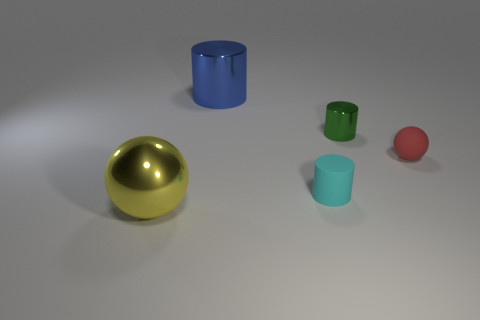There is a tiny green thing; is its shape the same as the big shiny thing in front of the red object?
Ensure brevity in your answer.  No. Are there any big blue things of the same shape as the yellow object?
Keep it short and to the point. No. The small matte thing behind the rubber object to the left of the red rubber thing is what shape?
Provide a short and direct response. Sphere. What shape is the shiny thing on the left side of the blue object?
Provide a succinct answer. Sphere. What number of cylinders are both left of the tiny green metal thing and behind the tiny sphere?
Your response must be concise. 1. The cyan object that is made of the same material as the tiny ball is what size?
Provide a succinct answer. Small. The red sphere has what size?
Ensure brevity in your answer.  Small. What is the material of the tiny cyan object?
Your answer should be very brief. Rubber. There is a cylinder that is left of the cyan rubber cylinder; is its size the same as the small cyan rubber object?
Offer a terse response. No. How many objects are either small metal objects or matte objects?
Offer a very short reply. 3. 